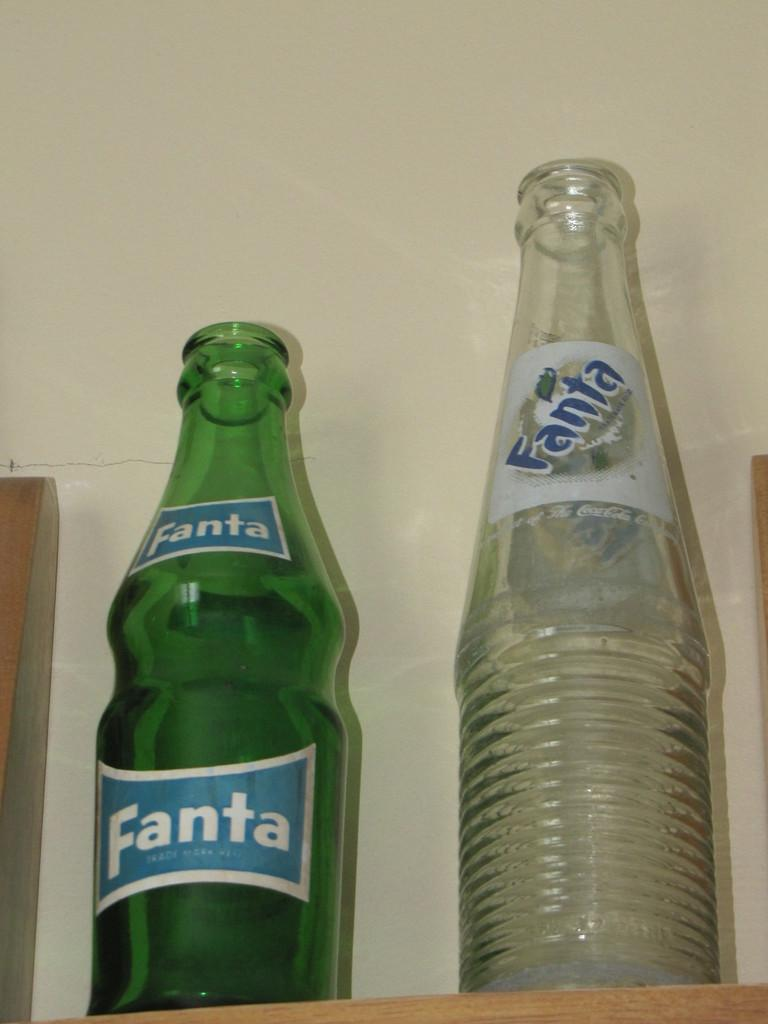Provide a one-sentence caption for the provided image. Left side tall green bottle with the words Fanta in a white bordered blue label. 